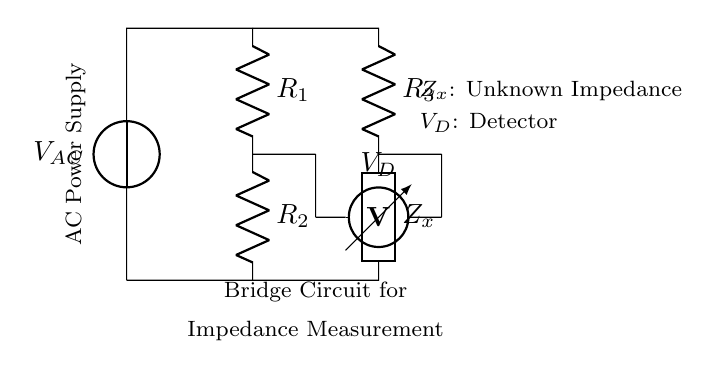What is the power supply type used in this circuit? The circuit uses an alternating current (AC) power supply, as indicated by the label on the voltage source in the diagram.
Answer: AC What is the purpose of the component labeled Z_x? The component Z_x represents an unknown impedance that is being measured by the bridge circuit. This is the primary function of the circuit.
Answer: Unknown Impedance How many resistors are in this circuit? There are three resistors in the circuit, labeled R_1, R_2, and R_3.
Answer: Three What is the function of the voltmeter in this circuit? The voltmeter, labeled V_D, is used to detect the voltage difference between the two points in the bridge. Its reading is crucial for determining the balance of the bridge and the unknown impedance.
Answer: Detector What is the balance condition for this bridge circuit? The balance condition occurs when the voltage across the voltmeter V_D is zero, indicating that the ratio of resistances satisfies the bridge equation, allowing for the calculation of the unknown impedance Z_x.
Answer: Voltage equals zero What happens to the measurement if the unknown impedance Z_x is greater than the other resistances? If Z_x is greater than the other resistances, the bridge will not be balanced, resulting in a non-zero voltage reading on the voltmeter V_D, which indicates the need for adjustments in the resistors to achieve balance.
Answer: Non-zero voltage reading How can the unknown impedance Z_x be determined from this circuit? The unknown impedance Z_x can be calculated using the bridge balance equation: Z_x = (R_2/R_1) * R_3 when the voltmeter reads zero. This equation relates the known resistor values to the unknown impedance.
Answer: Through calculated ratios 